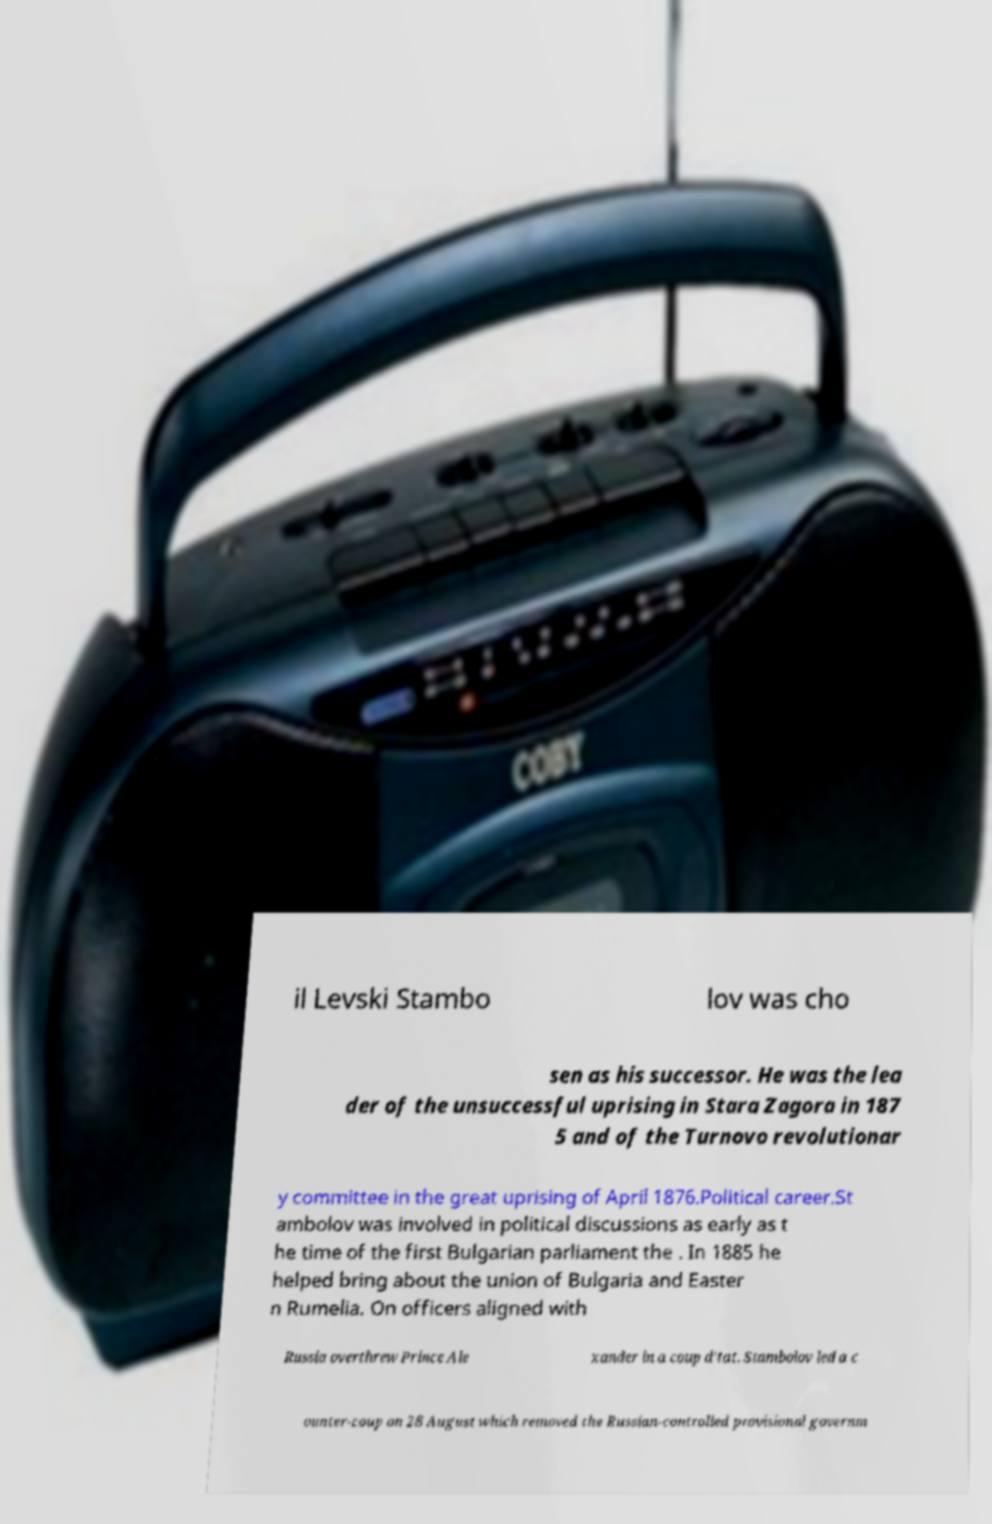Can you read and provide the text displayed in the image?This photo seems to have some interesting text. Can you extract and type it out for me? il Levski Stambo lov was cho sen as his successor. He was the lea der of the unsuccessful uprising in Stara Zagora in 187 5 and of the Turnovo revolutionar y committee in the great uprising of April 1876.Political career.St ambolov was involved in political discussions as early as t he time of the first Bulgarian parliament the . In 1885 he helped bring about the union of Bulgaria and Easter n Rumelia. On officers aligned with Russia overthrew Prince Ale xander in a coup d'tat. Stambolov led a c ounter-coup on 28 August which removed the Russian-controlled provisional governm 